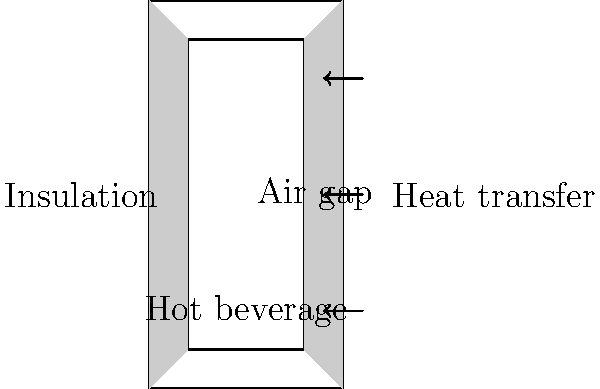As an innovative beverage enthusiast, you're designing a thermos flask to keep your morning brew hot. If the thermal conductivity of the air gap is $0.024$ W/(m·K) and the insulation material has a thermal conductivity of $0.040$ W/(m·K), how much more effective is the air gap at reducing heat transfer compared to the insulation material, assuming all other factors are equal? Let's approach this step-by-step:

1) The effectiveness of insulation is inversely proportional to its thermal conductivity. Lower thermal conductivity means better insulation.

2) We are given:
   - Thermal conductivity of air gap: $k_a = 0.024$ W/(m·K)
   - Thermal conductivity of insulation material: $k_i = 0.040$ W/(m·K)

3) To compare their effectiveness, we can calculate the ratio of their thermal conductivities:

   $\text{Ratio} = \frac{k_i}{k_a} = \frac{0.040}{0.024} = 1.667$

4) This means the insulation material allows 1.667 times more heat transfer than the air gap.

5) To express how much more effective the air gap is, we can subtract 1 from this ratio and convert to a percentage:

   $\text{Effectiveness} = (1.667 - 1) \times 100\% = 0.667 \times 100\% = 66.7\%$

Therefore, the air gap is approximately 66.7% more effective at reducing heat transfer than the insulation material.
Answer: 66.7% more effective 